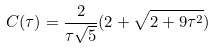Convert formula to latex. <formula><loc_0><loc_0><loc_500><loc_500>C ( \tau ) = \frac { 2 } { \tau \sqrt { 5 } } ( 2 + \sqrt { 2 + 9 \tau ^ { 2 } } )</formula> 